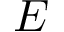<formula> <loc_0><loc_0><loc_500><loc_500>E</formula> 